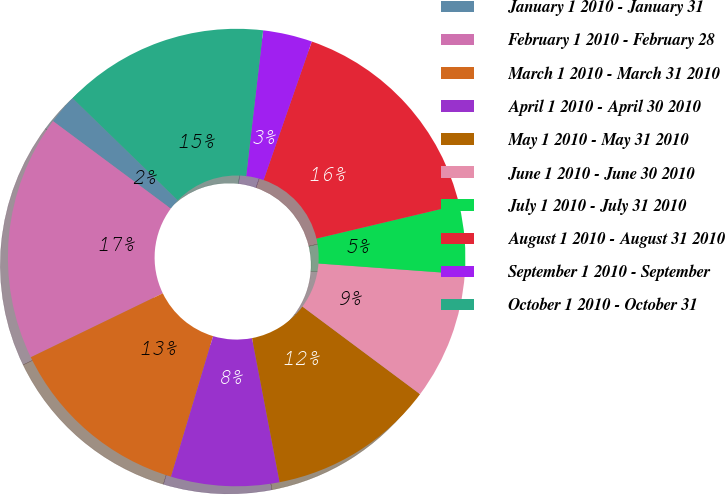Convert chart. <chart><loc_0><loc_0><loc_500><loc_500><pie_chart><fcel>January 1 2010 - January 31<fcel>February 1 2010 - February 28<fcel>March 1 2010 - March 31 2010<fcel>April 1 2010 - April 30 2010<fcel>May 1 2010 - May 31 2010<fcel>June 1 2010 - June 30 2010<fcel>July 1 2010 - July 31 2010<fcel>August 1 2010 - August 31 2010<fcel>September 1 2010 - September<fcel>October 1 2010 - October 31<nl><fcel>2.1%<fcel>17.35%<fcel>13.19%<fcel>7.64%<fcel>11.8%<fcel>9.03%<fcel>4.87%<fcel>15.96%<fcel>3.48%<fcel>14.58%<nl></chart> 